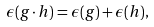Convert formula to latex. <formula><loc_0><loc_0><loc_500><loc_500>\epsilon ( g \cdot h ) = \epsilon ( g ) + \epsilon ( h ) ,</formula> 